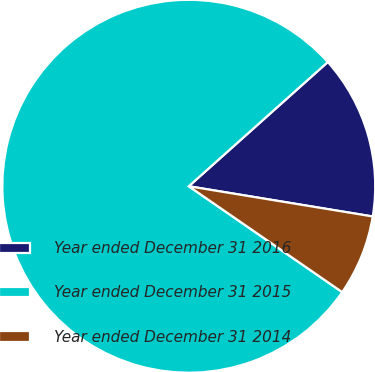Convert chart to OTSL. <chart><loc_0><loc_0><loc_500><loc_500><pie_chart><fcel>Year ended December 31 2016<fcel>Year ended December 31 2015<fcel>Year ended December 31 2014<nl><fcel>14.2%<fcel>78.78%<fcel>7.02%<nl></chart> 